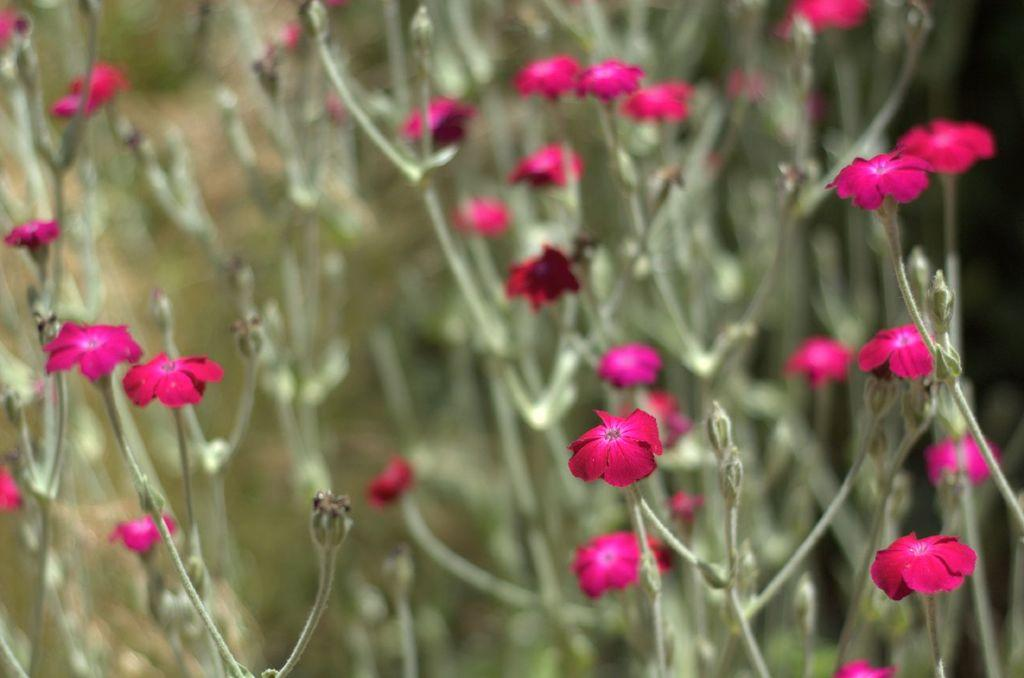What type of living organisms can be seen in the image? There are flowers and plants visible in the image. Can you describe the background of the image? The background of the image is blurred. What type of underwear is being argued about in the image? There is no underwear or argument present in the image; it features flowers and plants with a blurred background. 